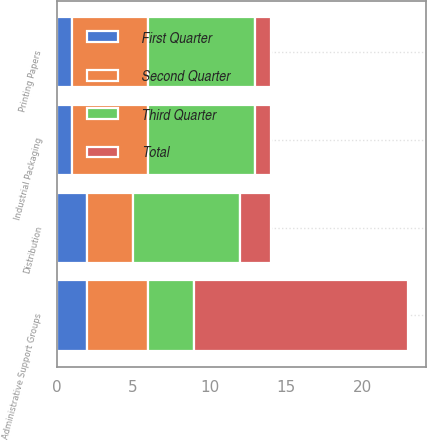Convert chart to OTSL. <chart><loc_0><loc_0><loc_500><loc_500><stacked_bar_chart><ecel><fcel>Printing Papers<fcel>Industrial Packaging<fcel>Distribution<fcel>Administrative Support Groups<nl><fcel>First Quarter<fcel>1<fcel>1<fcel>2<fcel>2<nl><fcel>Total<fcel>1<fcel>1<fcel>2<fcel>14<nl><fcel>Second Quarter<fcel>5<fcel>5<fcel>3<fcel>4<nl><fcel>Third Quarter<fcel>7<fcel>7<fcel>7<fcel>3<nl></chart> 